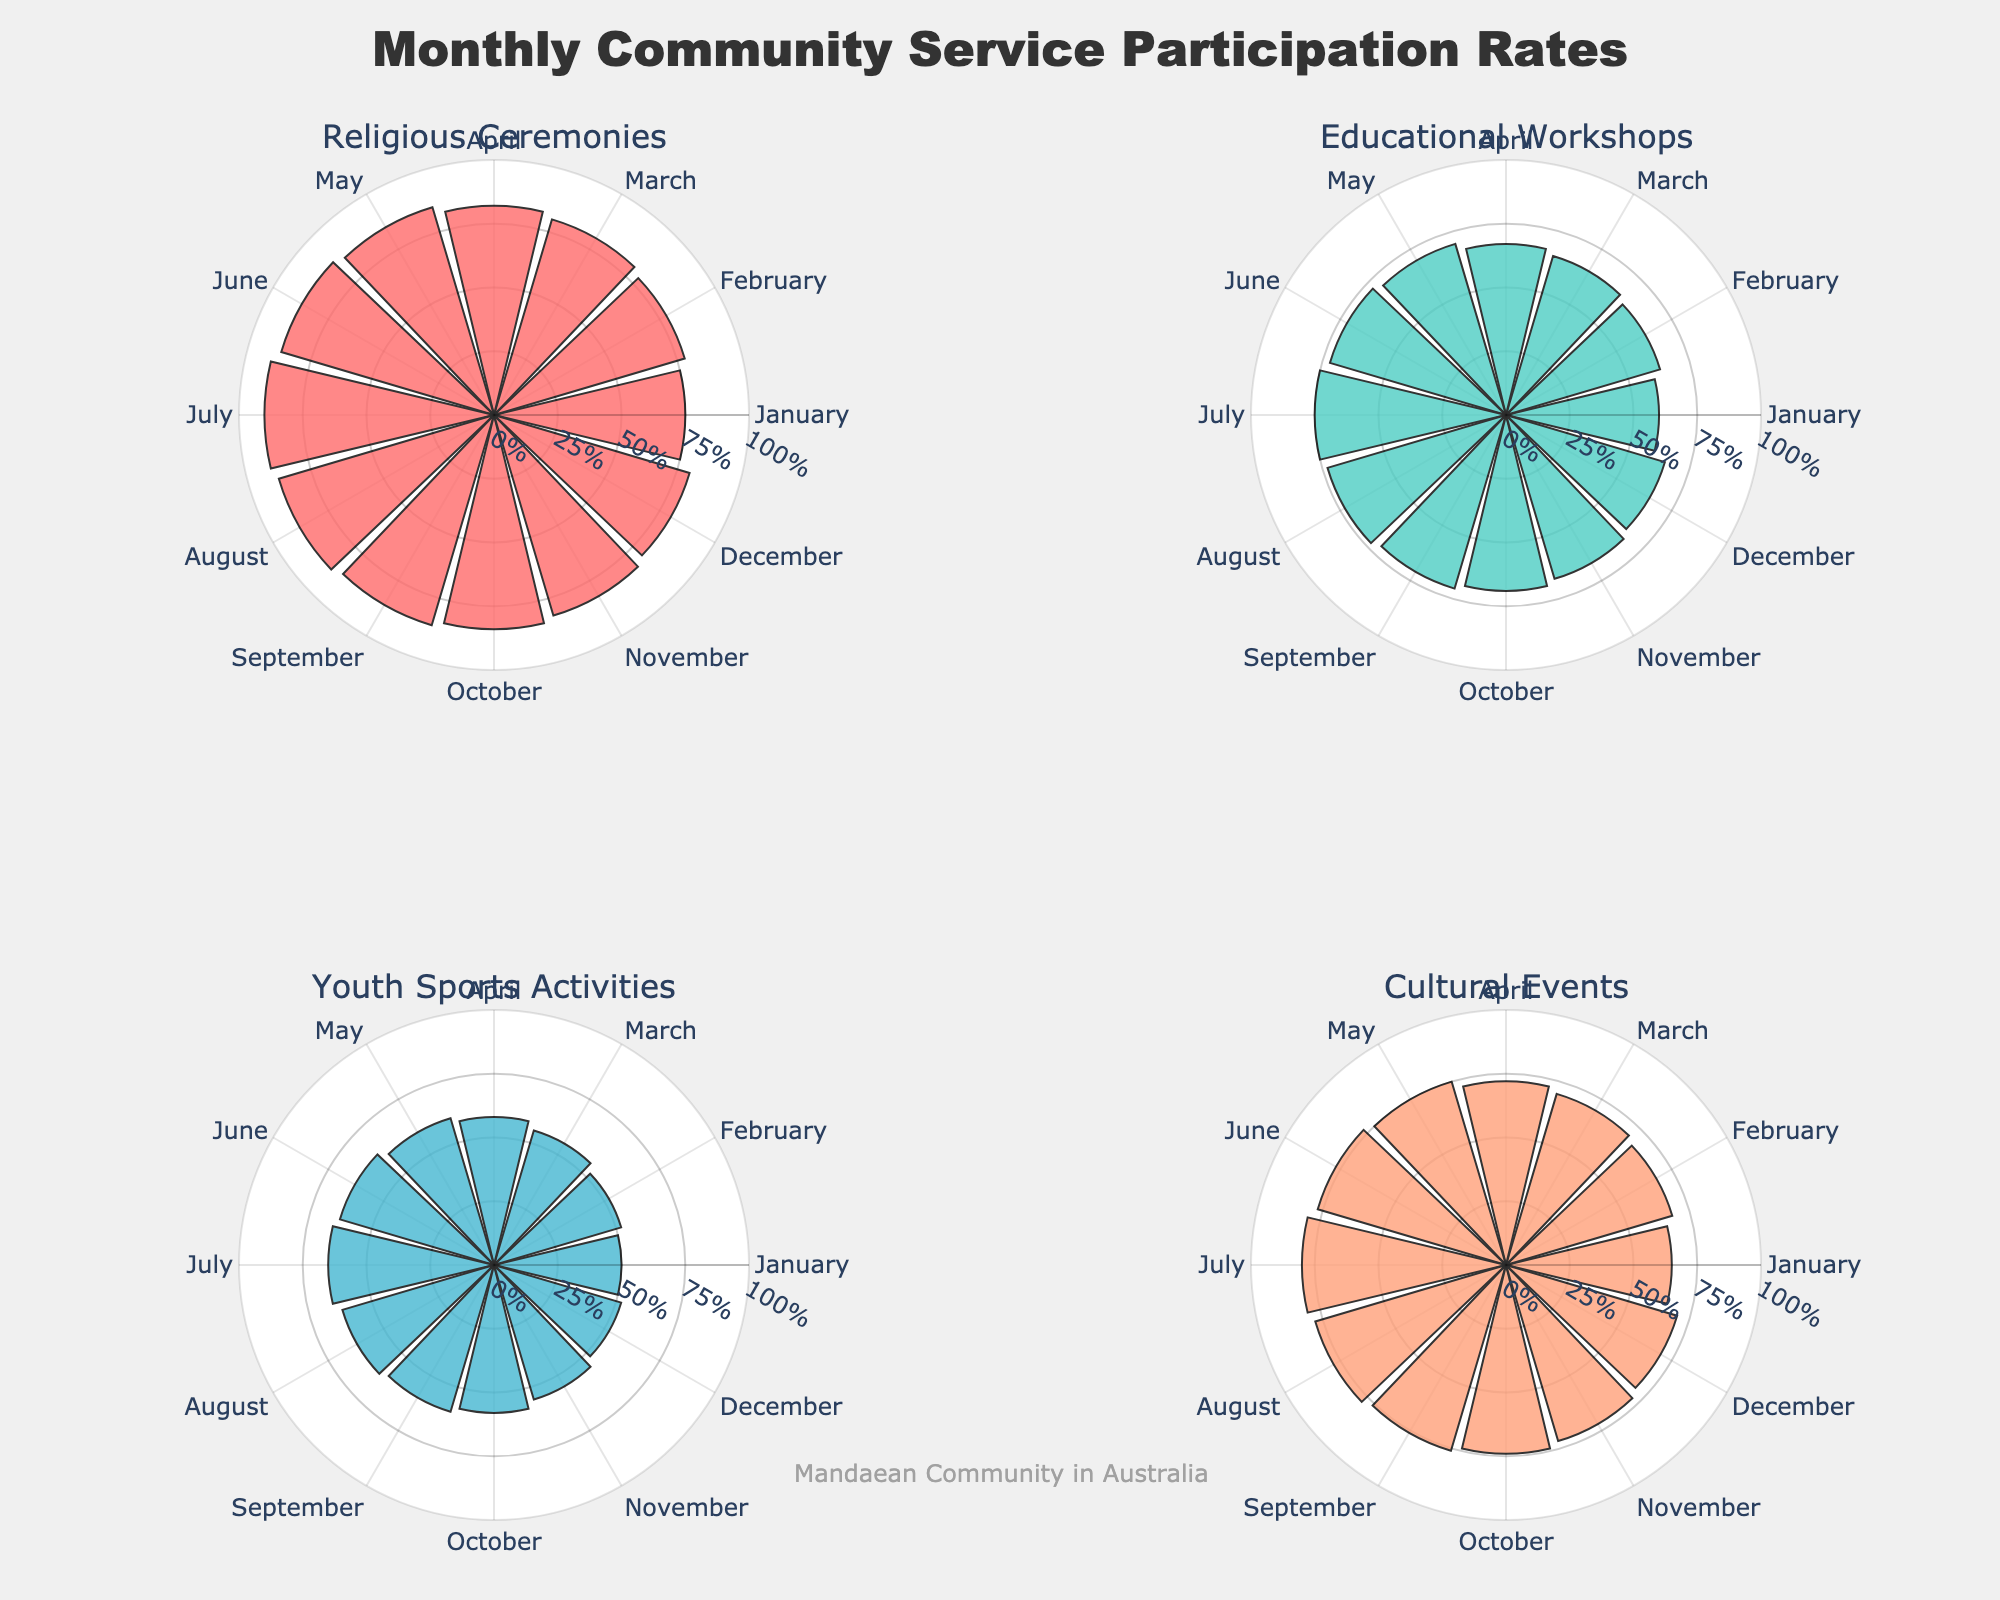Which month has the highest participation rate for Religious Ceremonies? To determine this, look at the "Religious Ceremonies" subplot and find the month with the longest bar. The longest bar corresponds to July with a participation rate of 90%.
Answer: July What is the average participation rate for Educational Workshops from January to December? First, gather the participation rates for Educational Workshops: (60, 63, 65, 67, 70, 72, 75, 73, 71, 69, 67, 65). Sum these values to get 817 and then divide by 12 (the number of months).
Answer: 68.08% Comparing Youth Sports Activities, which month has a lower participation rate: April or December? Examine the "Youth Sports Activities" subplot and compare the lengths of the bars for April and December. April has a participation rate of 58%, and December has a rate of 52%. Since 52% is lower than 58%, December has a lower participation rate.
Answer: December Which service has the least variability in participation rates over the months? To find this, inspect the subplots and look for the one where the participation bars are most consistent in length. "Youth Sports Activities" seems to have the smallest difference between the highest (65%) and lowest (50%) participation rates.
Answer: Youth Sports Activities During which month do Cultural Events have the highest participation rate? Look at the "Cultural Events" subplot and identify the month with the longest bar. The longest bar corresponds to July with a participation rate of 80%.
Answer: July What is the difference between the highest and the lowest participation rates for Religious Ceremonies? Look at the "Religious Ceremonies" subplot and note the highest participation rate (90% in July) and the lowest (75% in January). The difference is calculated as 90% - 75% = 15%.
Answer: 15% Which month shows the highest participation rate for two different services, and what are those services? Review each subplot and observe which month occurs most frequently with the highest participation rate. Both "Religious Ceremonies" and "Cultural Events" have their highest rates in July (90% and 80%, respectively).
Answer: July, Religious Ceremonies and Cultural Events 